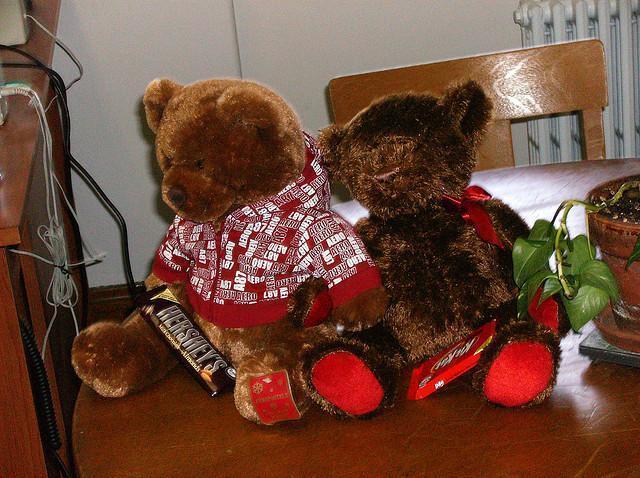What kind of candy bar is hanging on the leg of the teddy with a hoodie sweater put on?
Pick the correct solution from the four options below to address the question.
Options: Kit kat, hersheys, payday, mars. Hersheys. 